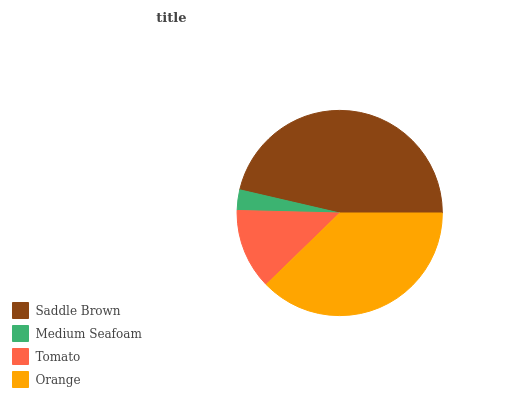Is Medium Seafoam the minimum?
Answer yes or no. Yes. Is Saddle Brown the maximum?
Answer yes or no. Yes. Is Tomato the minimum?
Answer yes or no. No. Is Tomato the maximum?
Answer yes or no. No. Is Tomato greater than Medium Seafoam?
Answer yes or no. Yes. Is Medium Seafoam less than Tomato?
Answer yes or no. Yes. Is Medium Seafoam greater than Tomato?
Answer yes or no. No. Is Tomato less than Medium Seafoam?
Answer yes or no. No. Is Orange the high median?
Answer yes or no. Yes. Is Tomato the low median?
Answer yes or no. Yes. Is Medium Seafoam the high median?
Answer yes or no. No. Is Medium Seafoam the low median?
Answer yes or no. No. 